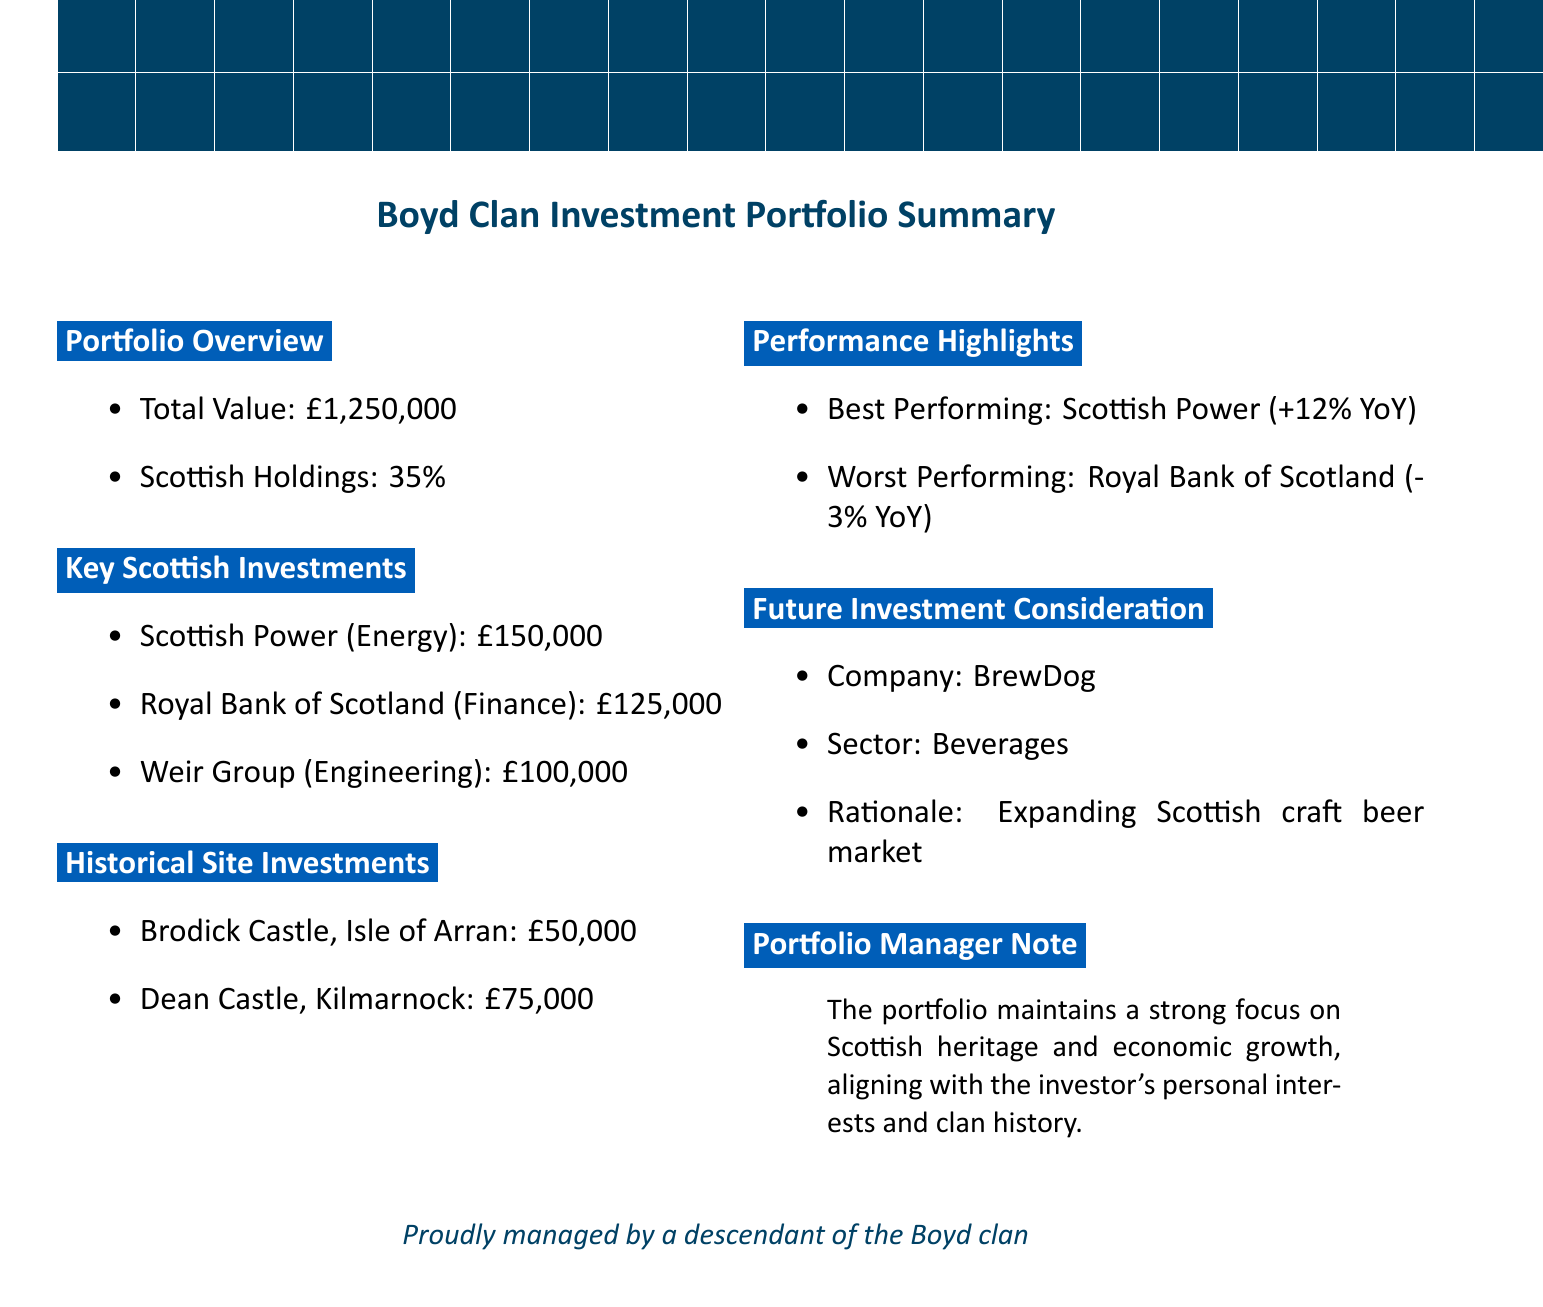What is the total value of the portfolio? The total value is explicitly stated in the document as £1,250,000.
Answer: £1,250,000 What percentage of the portfolio comprises Scottish holdings? The document specifies that Scottish holdings make up 35% of the portfolio.
Answer: 35% Which company is the best performing in the portfolio? The best performing company is mentioned as Scottish Power with a performance increase of 12%.
Answer: Scottish Power What is the investment value in Dean Castle? The document lists the investment value for Dean Castle as £75,000.
Answer: £75,000 What is the rationale for considering future investment in BrewDog? The rationale provided in the document is due to the expanding Scottish craft beer market.
Answer: Expanding Scottish craft beer market How much has been invested in Royal Bank of Scotland? The document states the investment value for Royal Bank of Scotland is £125,000.
Answer: £125,000 What historical connection is mentioned for Brodick Castle? The document indicates that Brodick Castle is the former seat of the Boyd clan.
Answer: Former seat of the Boyd clan What sector does Weir Group operate in? Weir Group is categorized under the engineering sector in the document.
Answer: Engineering What note does the portfolio manager provide? The portfolio manager's note highlights the focus on Scottish heritage and economic growth.
Answer: Focus on Scottish heritage and economic growth 